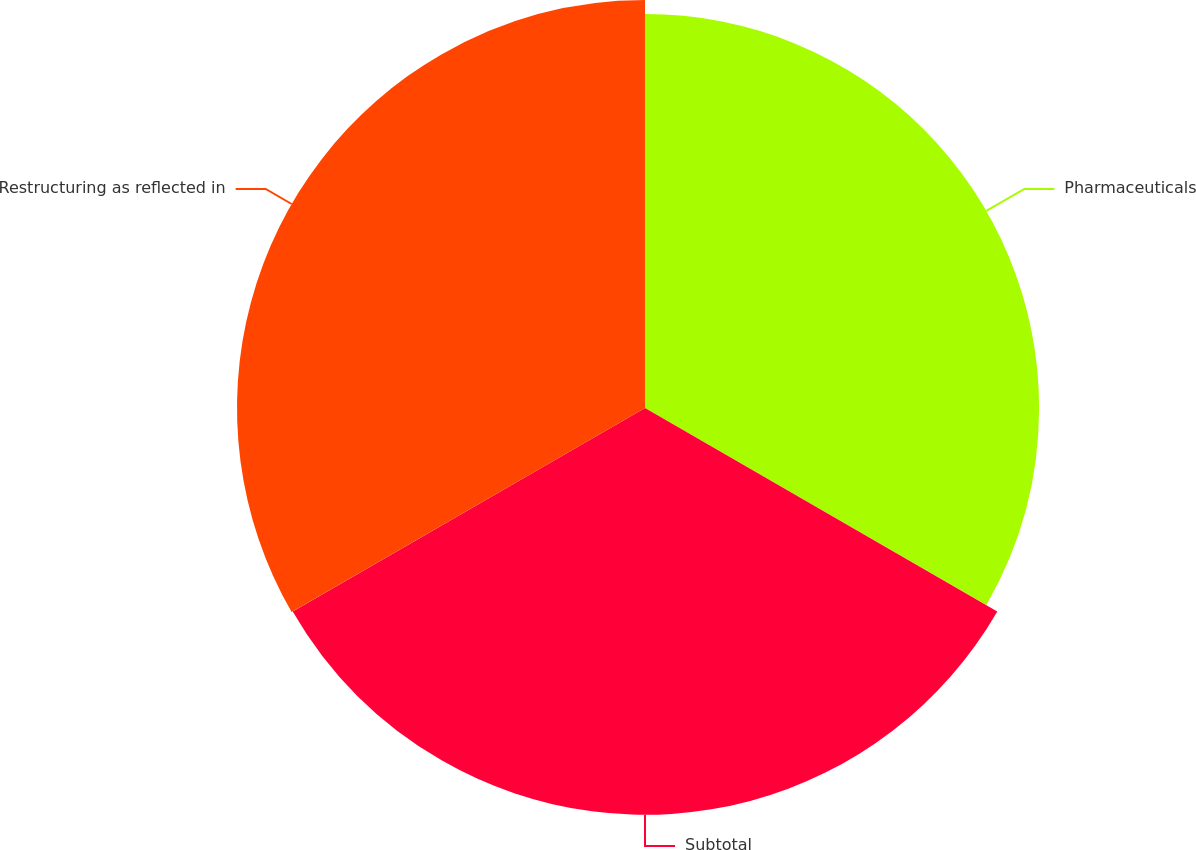Convert chart. <chart><loc_0><loc_0><loc_500><loc_500><pie_chart><fcel>Pharmaceuticals<fcel>Subtotal<fcel>Restructuring as reflected in<nl><fcel>32.6%<fcel>33.65%<fcel>33.75%<nl></chart> 